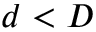<formula> <loc_0><loc_0><loc_500><loc_500>d < D</formula> 